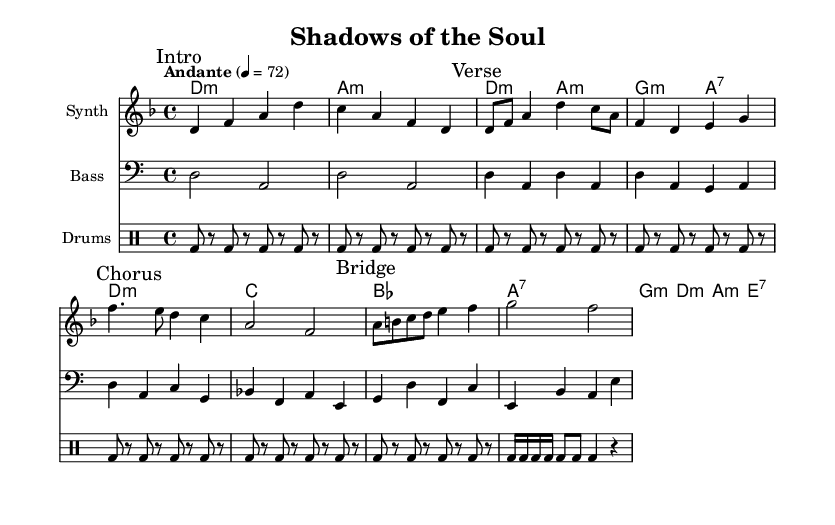What is the key signature of this music? The key signature is D minor, indicated by one flat (B flat). This is evident from the 'key d \minor' line in the global settings.
Answer: D minor What is the time signature? The time signature is 4/4, which is shown in the global settings with '\time 4/4'. This means there are four beats in each measure.
Answer: 4/4 What is the tempo marking? The tempo is marked as Andante, which is indicated by 'Andante' followed by '4 = 72'. This means the piece should be played at a moderate speed.
Answer: Andante Which instrument plays the melody? The melody is played by the Synth, which is specified in the staff context as 'instrumentName = "Synth"'.
Answer: Synth What type of harmony is primarily used? The harmony is primarily minor, indicated by the use of 'm' in the chord names like 'd1:m' and 'a:m', suggesting a dark and somber tone typical of darkwave music.
Answer: Minor What is unique about the drum pattern in this piece? The drum pattern features a repeating kick drum rhythm that is steady and consistent, which is a characteristic feature of electronic music, providing a driving force and maintaining the tempo.
Answer: Repeating kick drum 